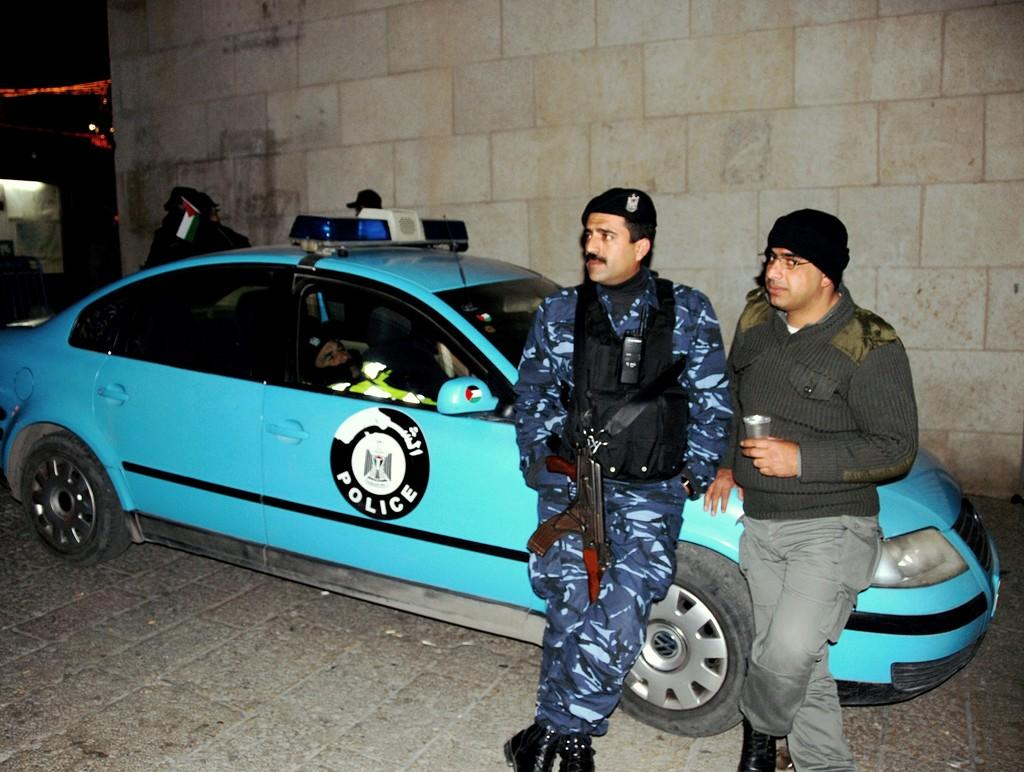How many people are in the image? There are two persons standing in the image. What is the surface they are standing on? The persons are standing on the floor. What else can be seen in the image besides the people? There is a car in the image, and a person is inside the car. What is visible in the background of the image? There is a wall visible in the image. What type of linen is draped over the car in the image? There is no linen draped over the car in the image. Can you describe the facial expressions of the people in the image? The provided facts do not mention facial expressions, so it is not possible to describe them. 